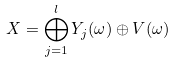<formula> <loc_0><loc_0><loc_500><loc_500>X = \bigoplus _ { j = 1 } ^ { l } Y _ { j } ( \omega ) \oplus V ( \omega )</formula> 